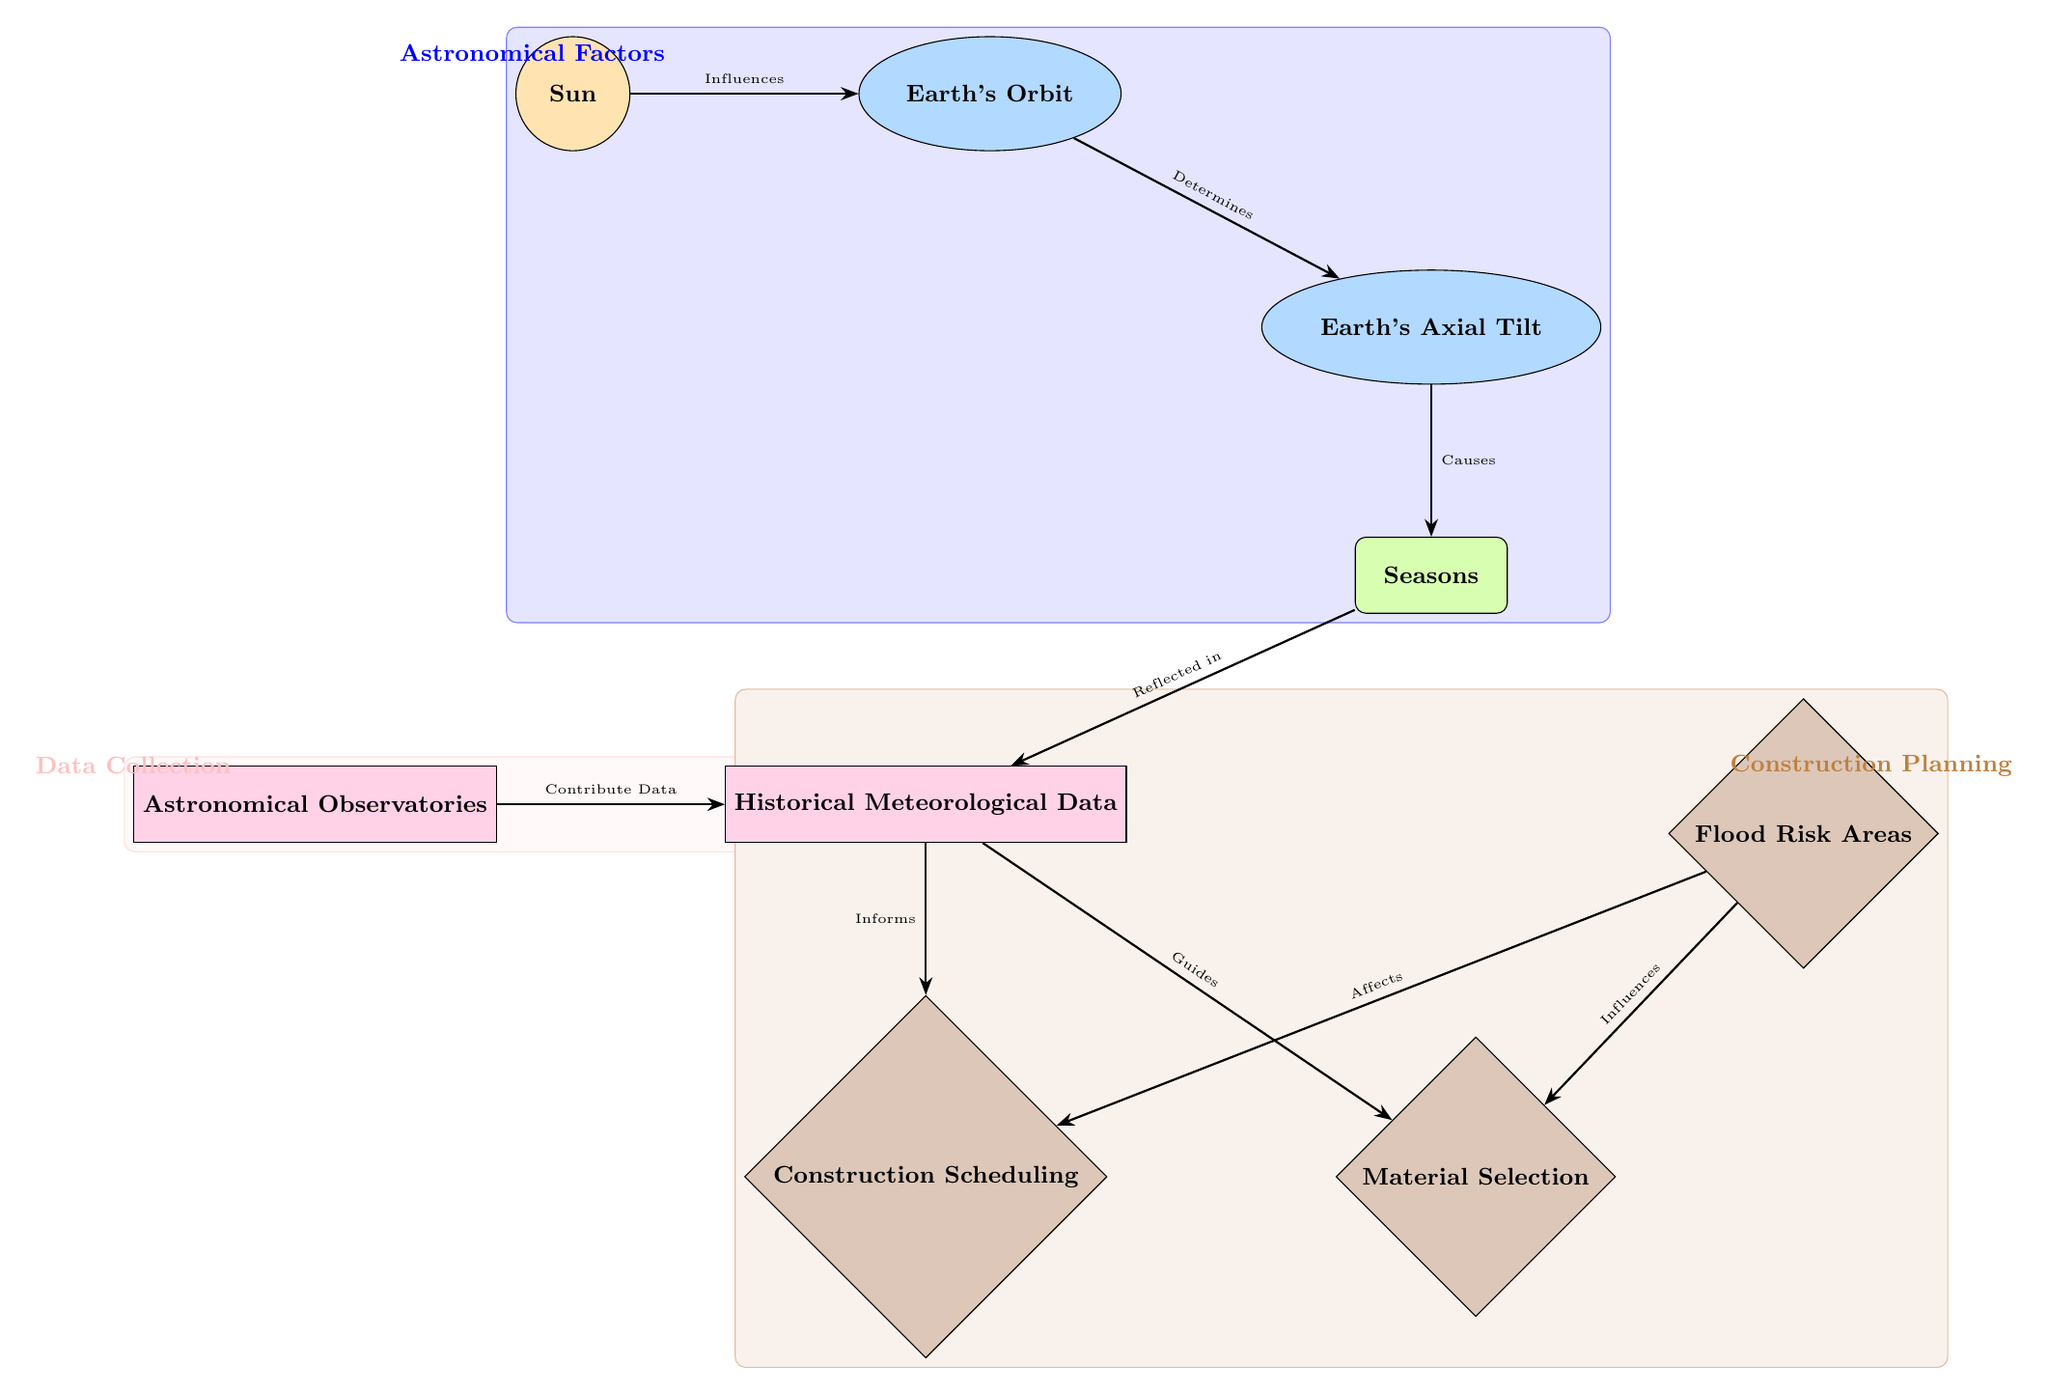What is the color of the node representing the Sun? The Sun node is colored in suncolor, which is a shade of orange. This can be identified by looking at the node labeled "Sun" in the diagram, which is painted in a light orange hue.
Answer: orange How many nodes are in the "Construction Planning" section? The "Construction Planning" section consists of three nodes: "Flood Risk Areas," "Construction Scheduling," and "Material Selection." By counting each of these nodes, we can confirm the total.
Answer: 3 What influences the Earth's Orbit? According to the diagram, the Sun influences the Earth's Orbit. This relationship is indicated by the arrow connecting the "Sun" node to the "Earth's Orbit" node, with the label "Influences" on it.
Answer: Sun What data contributes to the Historical Meteorological Data? The diagram indicates that data from "Astronomical Observatories" contribute to "Historical Meteorological Data." This can be confirmed by looking for the arrow connecting the "Astronomical Observatories" to "Historical Meteorological Data."
Answer: Astronomical Observatories How does the Flood Risk Areas node affect Construction Scheduling? The "Flood Risk Areas" node affects the "Construction Scheduling" node, as indicated by the arrow labeled "Affects." The flow from "Flood Risk Areas" to "Construction Scheduling" indicates that flood risk can influence when construction activities are scheduled.
Answer: Affects What does the Earth's Axial Tilt determine? The Earth's Axial Tilt determines the Earth's Orbit. This is clear from the diagram where the "Earth's Axial Tilt" node points toward the "Earth's Orbit" node, marked with the label "Determines."
Answer: Earth's Orbit Which node reflects in Meteorological Data? The node titled "Seasons" reflects in "Historical Meteorological Data." This relationship is shown in the diagram by the arrow connecting "Seasons" to "Historical Meteorological Data," annotated with "Reflected in."
Answer: Seasons Which two aspects are guided by Historical Meteorological Data? "Construction Scheduling" and "Material Selection" are both guided by "Historical Meteorological Data," with arrows coming out of the "Historical Meteorological Data" node that connect to each of these nodes, annotated with "Informs" and "Guides," respectively.
Answer: Construction Scheduling and Material Selection What causes the seasons? The cause of the seasons is labeled as "Earth's Axial Tilt" in the diagram. This is shown by the arrow connecting the "Earth's Axial Tilt" node to the "Seasons" node, indicating a direct causal relationship.
Answer: Earth's Axial Tilt 